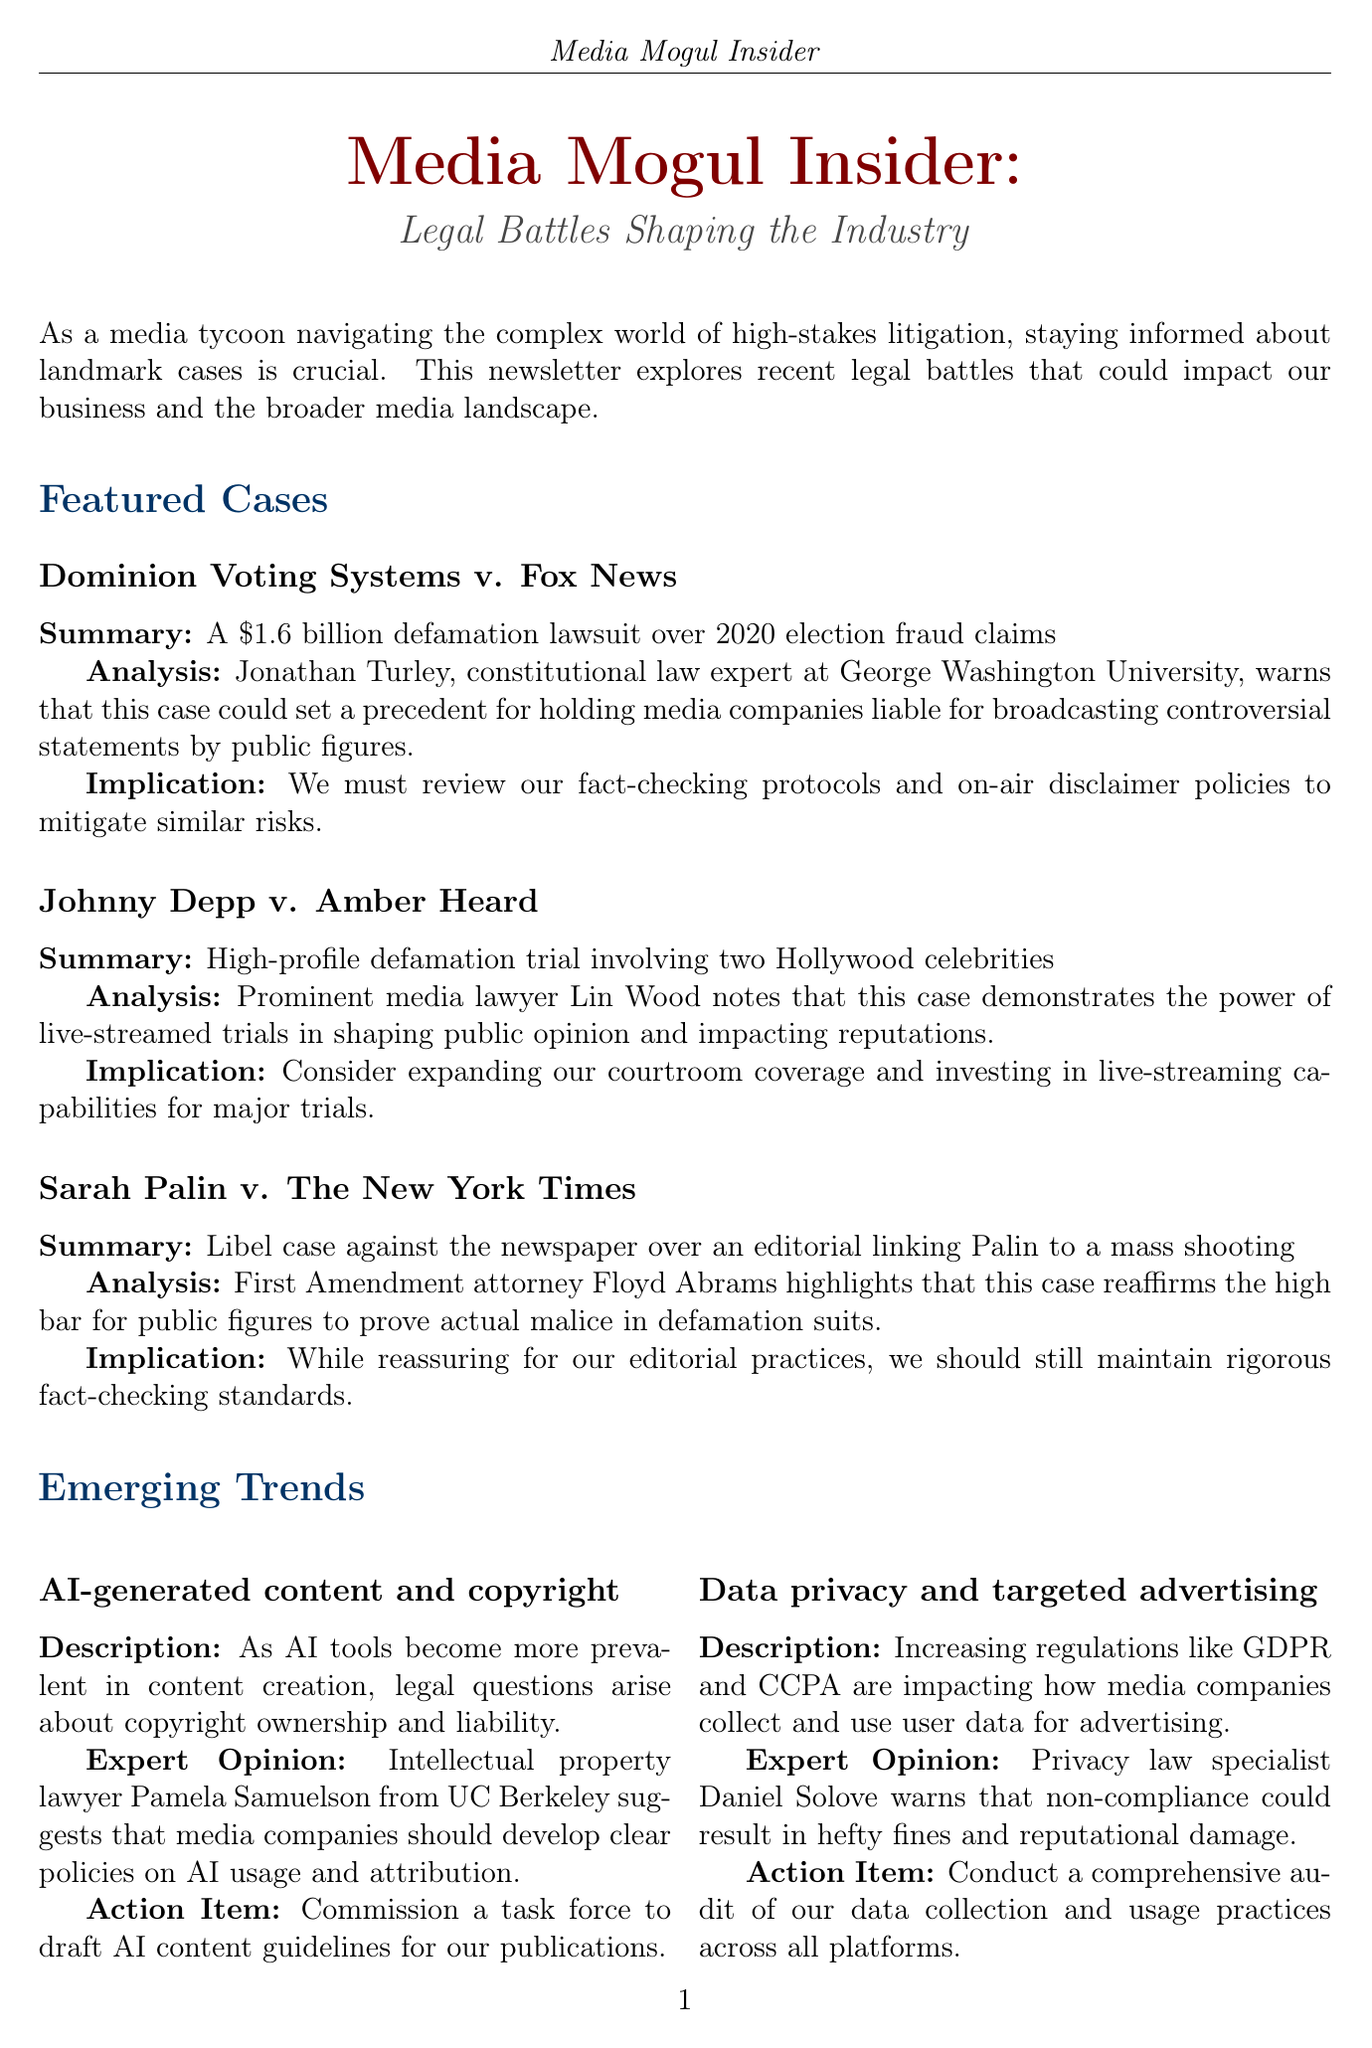What is the title of the newsletter? The title of the newsletter is explicitly stated at the beginning of the document.
Answer: Media Mogul Insider: Legal Battles Shaping the Industry How much is the Dominion Voting Systems v. Fox News lawsuit for? The document provides the monetary amount related to the lawsuit, which is mentioned in the summary.
Answer: 1.6 billion Who is the expert analyzing the Dominion Voting Systems case? The document identifies the expert providing analysis for this specific case.
Answer: Jonathan Turley What implication is mentioned regarding the Sarah Palin case? The document outlines the implications following the analysis of the Sarah Palin case.
Answer: Maintain rigorous fact-checking standards What emerging trend addresses copyright issues? The document lists various emerging trends and specifies the one related to copyright.
Answer: AI-generated content and copyright What is the action item for the trend on data privacy? The document summarizes key actions to be taken in response to emerging trends, specifically regarding data privacy.
Answer: Conduct a comprehensive audit Who is the featured attorney in the legal team spotlight? The document highlights a specific attorney in the section spotlighting the legal team.
Answer: Gloria Allred What does Gloria Allred emphasize about public perception? The document includes a quote from Gloria Allred regarding the importance of public perception in media.
Answer: Managing public perception What are the names of the two parties in the Johnny Depp case? The document mentions the parties involved in this high-profile case.
Answer: Johnny Depp and Amber Heard 